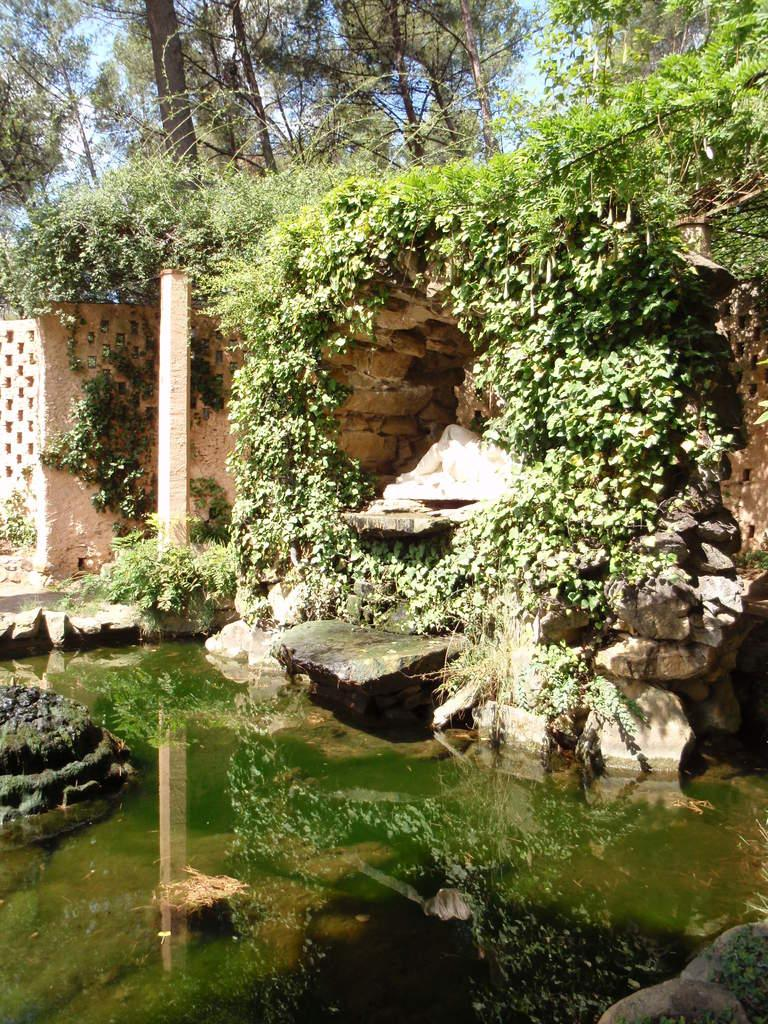What is the primary element visible in the image? There is water in the image. What other objects or features can be seen in the image? There are rocks, a wall, trees, and the sky visible in the image. Can you describe the natural elements present in the image? The image features water, rocks, trees, and the sky. What type of structure is present in the image? There is a wall in the image. What color is the yarn being used by the sisters in the image? There are no sisters or yarn present in the image. How many lines can be seen connecting the trees in the image? There are no lines connecting the trees in the image. 